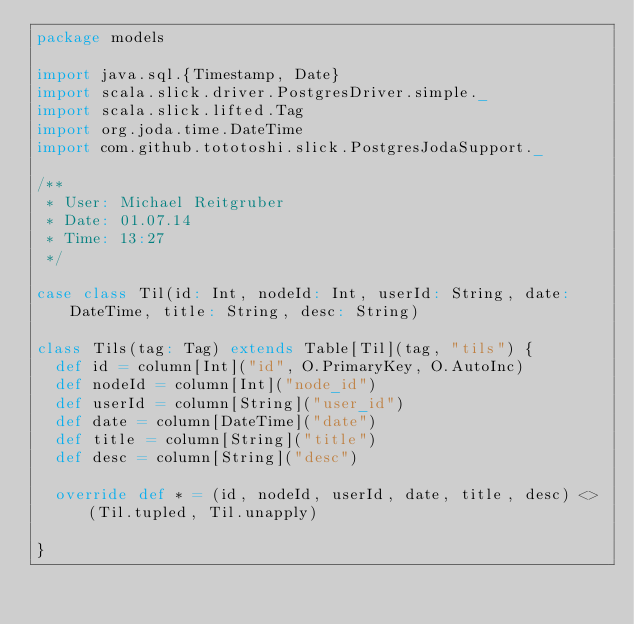<code> <loc_0><loc_0><loc_500><loc_500><_Scala_>package models

import java.sql.{Timestamp, Date}
import scala.slick.driver.PostgresDriver.simple._
import scala.slick.lifted.Tag
import org.joda.time.DateTime
import com.github.tototoshi.slick.PostgresJodaSupport._

/**
 * User: Michael Reitgruber
 * Date: 01.07.14
 * Time: 13:27
 */

case class Til(id: Int, nodeId: Int, userId: String, date: DateTime, title: String, desc: String)

class Tils(tag: Tag) extends Table[Til](tag, "tils") {
  def id = column[Int]("id", O.PrimaryKey, O.AutoInc)
  def nodeId = column[Int]("node_id")
  def userId = column[String]("user_id")
  def date = column[DateTime]("date")
  def title = column[String]("title")
  def desc = column[String]("desc")

  override def * = (id, nodeId, userId, date, title, desc) <> (Til.tupled, Til.unapply)

}
</code> 